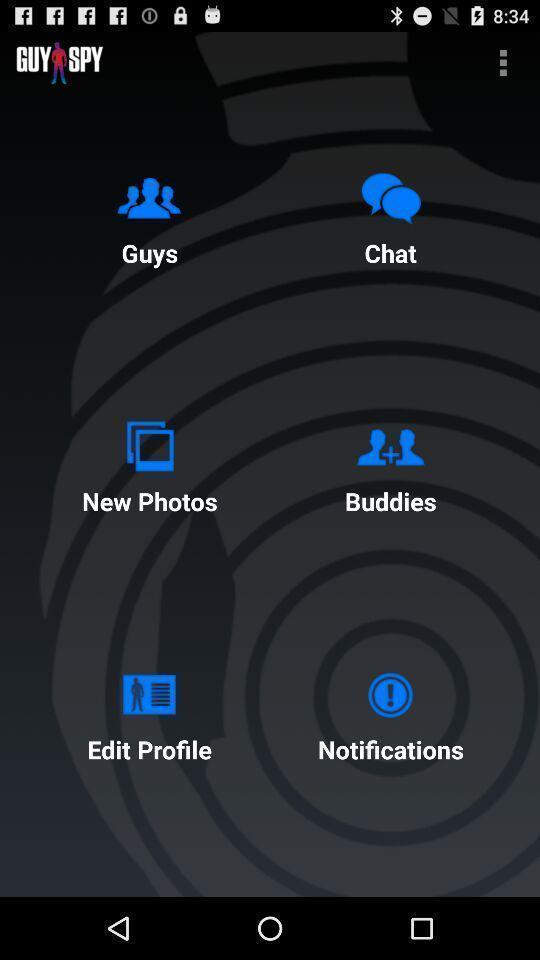Describe this image in words. Page showing different features from a chatting app. 